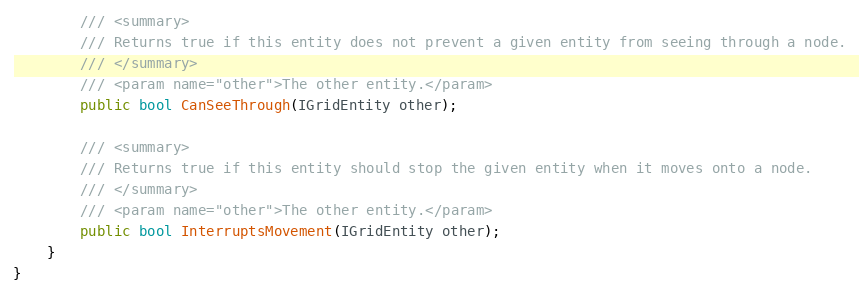<code> <loc_0><loc_0><loc_500><loc_500><_C#_>
        /// <summary>
        /// Returns true if this entity does not prevent a given entity from seeing through a node.
        /// </summary>
        /// <param name="other">The other entity.</param>
        public bool CanSeeThrough(IGridEntity other);

        /// <summary>
        /// Returns true if this entity should stop the given entity when it moves onto a node.
        /// </summary>
        /// <param name="other">The other entity.</param>
        public bool InterruptsMovement(IGridEntity other);
    }
}
</code> 